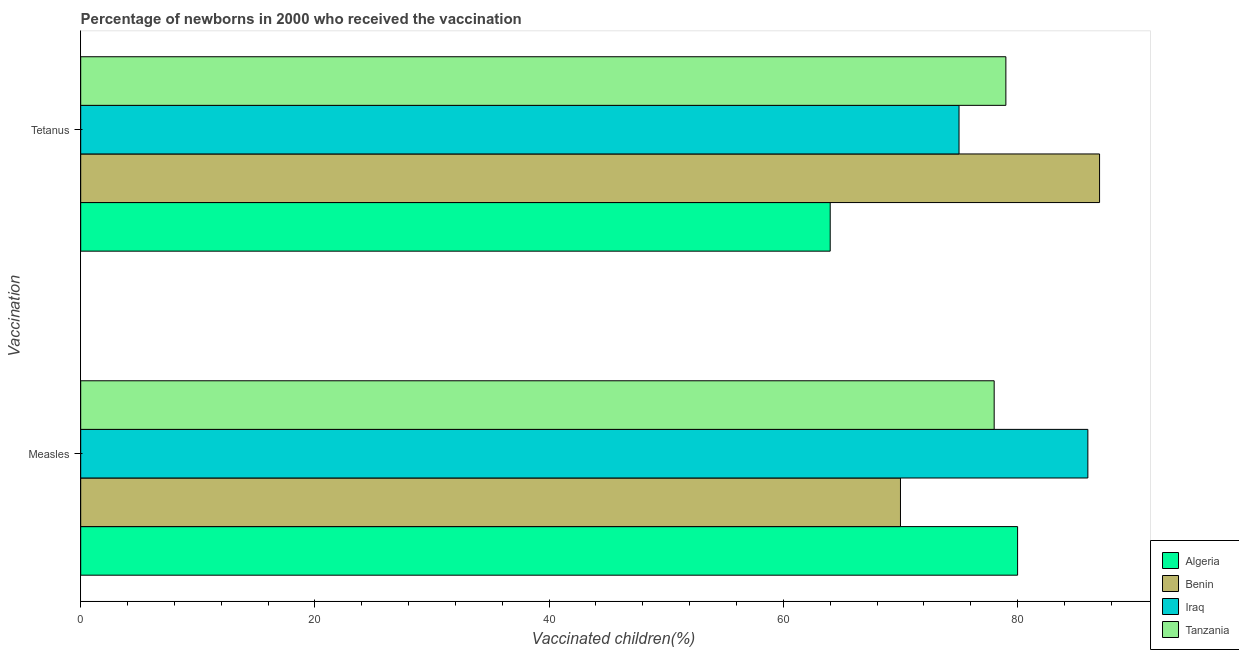How many different coloured bars are there?
Your response must be concise. 4. How many groups of bars are there?
Offer a terse response. 2. Are the number of bars on each tick of the Y-axis equal?
Make the answer very short. Yes. What is the label of the 2nd group of bars from the top?
Give a very brief answer. Measles. What is the percentage of newborns who received vaccination for tetanus in Iraq?
Make the answer very short. 75. Across all countries, what is the maximum percentage of newborns who received vaccination for measles?
Offer a terse response. 86. Across all countries, what is the minimum percentage of newborns who received vaccination for measles?
Offer a very short reply. 70. In which country was the percentage of newborns who received vaccination for measles maximum?
Keep it short and to the point. Iraq. In which country was the percentage of newborns who received vaccination for tetanus minimum?
Keep it short and to the point. Algeria. What is the total percentage of newborns who received vaccination for tetanus in the graph?
Ensure brevity in your answer.  305. What is the difference between the percentage of newborns who received vaccination for measles in Tanzania and that in Algeria?
Your answer should be compact. -2. What is the difference between the percentage of newborns who received vaccination for measles in Algeria and the percentage of newborns who received vaccination for tetanus in Tanzania?
Give a very brief answer. 1. What is the average percentage of newborns who received vaccination for tetanus per country?
Keep it short and to the point. 76.25. What is the difference between the percentage of newborns who received vaccination for tetanus and percentage of newborns who received vaccination for measles in Benin?
Offer a very short reply. 17. What is the ratio of the percentage of newborns who received vaccination for tetanus in Tanzania to that in Algeria?
Your answer should be very brief. 1.23. Is the percentage of newborns who received vaccination for tetanus in Iraq less than that in Algeria?
Give a very brief answer. No. What does the 4th bar from the top in Tetanus represents?
Provide a short and direct response. Algeria. What does the 1st bar from the bottom in Measles represents?
Your response must be concise. Algeria. Are all the bars in the graph horizontal?
Keep it short and to the point. Yes. How many countries are there in the graph?
Ensure brevity in your answer.  4. What is the difference between two consecutive major ticks on the X-axis?
Offer a terse response. 20. Are the values on the major ticks of X-axis written in scientific E-notation?
Your answer should be very brief. No. Does the graph contain any zero values?
Provide a short and direct response. No. Does the graph contain grids?
Provide a short and direct response. No. Where does the legend appear in the graph?
Ensure brevity in your answer.  Bottom right. How many legend labels are there?
Your answer should be compact. 4. How are the legend labels stacked?
Ensure brevity in your answer.  Vertical. What is the title of the graph?
Provide a succinct answer. Percentage of newborns in 2000 who received the vaccination. Does "Chad" appear as one of the legend labels in the graph?
Provide a succinct answer. No. What is the label or title of the X-axis?
Keep it short and to the point. Vaccinated children(%)
. What is the label or title of the Y-axis?
Your response must be concise. Vaccination. What is the Vaccinated children(%)
 of Algeria in Measles?
Provide a succinct answer. 80. What is the Vaccinated children(%)
 in Iraq in Measles?
Give a very brief answer. 86. What is the Vaccinated children(%)
 of Algeria in Tetanus?
Your answer should be very brief. 64. What is the Vaccinated children(%)
 in Benin in Tetanus?
Your answer should be very brief. 87. What is the Vaccinated children(%)
 of Tanzania in Tetanus?
Provide a short and direct response. 79. Across all Vaccination, what is the maximum Vaccinated children(%)
 of Algeria?
Keep it short and to the point. 80. Across all Vaccination, what is the maximum Vaccinated children(%)
 in Iraq?
Provide a short and direct response. 86. Across all Vaccination, what is the maximum Vaccinated children(%)
 in Tanzania?
Offer a terse response. 79. Across all Vaccination, what is the minimum Vaccinated children(%)
 of Benin?
Provide a short and direct response. 70. What is the total Vaccinated children(%)
 in Algeria in the graph?
Offer a very short reply. 144. What is the total Vaccinated children(%)
 of Benin in the graph?
Provide a succinct answer. 157. What is the total Vaccinated children(%)
 of Iraq in the graph?
Keep it short and to the point. 161. What is the total Vaccinated children(%)
 in Tanzania in the graph?
Your answer should be compact. 157. What is the difference between the Vaccinated children(%)
 in Benin in Measles and that in Tetanus?
Keep it short and to the point. -17. What is the difference between the Vaccinated children(%)
 in Benin in Measles and the Vaccinated children(%)
 in Tanzania in Tetanus?
Provide a short and direct response. -9. What is the average Vaccinated children(%)
 in Benin per Vaccination?
Keep it short and to the point. 78.5. What is the average Vaccinated children(%)
 in Iraq per Vaccination?
Make the answer very short. 80.5. What is the average Vaccinated children(%)
 in Tanzania per Vaccination?
Your answer should be compact. 78.5. What is the difference between the Vaccinated children(%)
 in Algeria and Vaccinated children(%)
 in Benin in Measles?
Your answer should be very brief. 10. What is the difference between the Vaccinated children(%)
 of Algeria and Vaccinated children(%)
 of Iraq in Measles?
Give a very brief answer. -6. What is the difference between the Vaccinated children(%)
 in Benin and Vaccinated children(%)
 in Iraq in Measles?
Provide a succinct answer. -16. What is the difference between the Vaccinated children(%)
 of Benin and Vaccinated children(%)
 of Tanzania in Measles?
Ensure brevity in your answer.  -8. What is the difference between the Vaccinated children(%)
 of Iraq and Vaccinated children(%)
 of Tanzania in Measles?
Your answer should be very brief. 8. What is the difference between the Vaccinated children(%)
 in Algeria and Vaccinated children(%)
 in Tanzania in Tetanus?
Offer a terse response. -15. What is the difference between the Vaccinated children(%)
 in Iraq and Vaccinated children(%)
 in Tanzania in Tetanus?
Provide a short and direct response. -4. What is the ratio of the Vaccinated children(%)
 of Benin in Measles to that in Tetanus?
Your answer should be compact. 0.8. What is the ratio of the Vaccinated children(%)
 of Iraq in Measles to that in Tetanus?
Give a very brief answer. 1.15. What is the ratio of the Vaccinated children(%)
 in Tanzania in Measles to that in Tetanus?
Your response must be concise. 0.99. What is the difference between the highest and the lowest Vaccinated children(%)
 in Algeria?
Keep it short and to the point. 16. What is the difference between the highest and the lowest Vaccinated children(%)
 of Tanzania?
Keep it short and to the point. 1. 